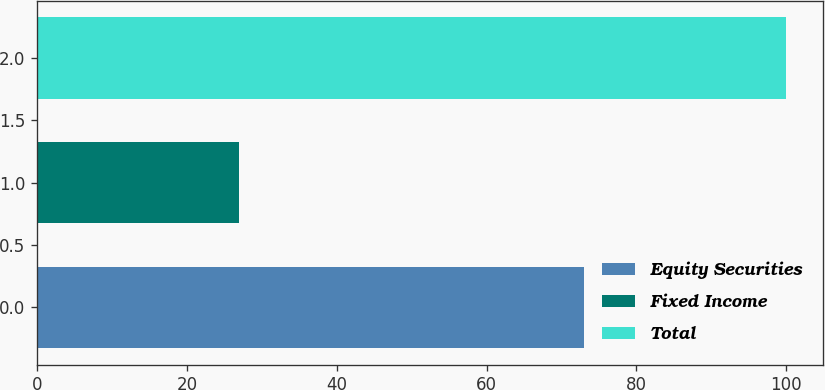Convert chart to OTSL. <chart><loc_0><loc_0><loc_500><loc_500><bar_chart><fcel>Equity Securities<fcel>Fixed Income<fcel>Total<nl><fcel>73<fcel>27<fcel>100<nl></chart> 